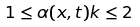<formula> <loc_0><loc_0><loc_500><loc_500>1 \leq \alpha ( x , t ) k \leq 2</formula> 